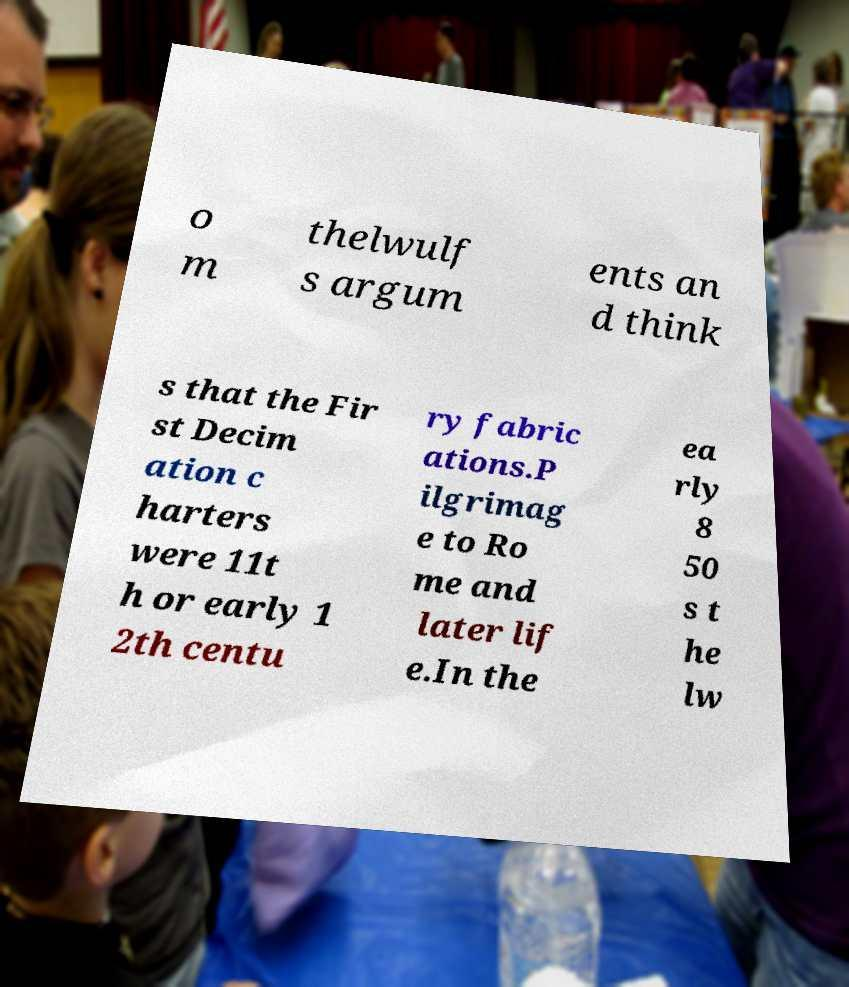For documentation purposes, I need the text within this image transcribed. Could you provide that? o m thelwulf s argum ents an d think s that the Fir st Decim ation c harters were 11t h or early 1 2th centu ry fabric ations.P ilgrimag e to Ro me and later lif e.In the ea rly 8 50 s t he lw 